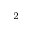Convert formula to latex. <formula><loc_0><loc_0><loc_500><loc_500>^ { 2 }</formula> 